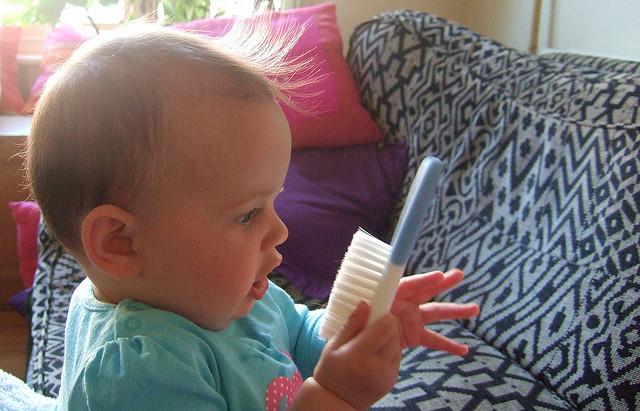Is the child happy?
Quick response, please. Yes. Is it daytime in this picture?
Short answer required. Yes. What is the child holding?
Write a very short answer. Brush. 